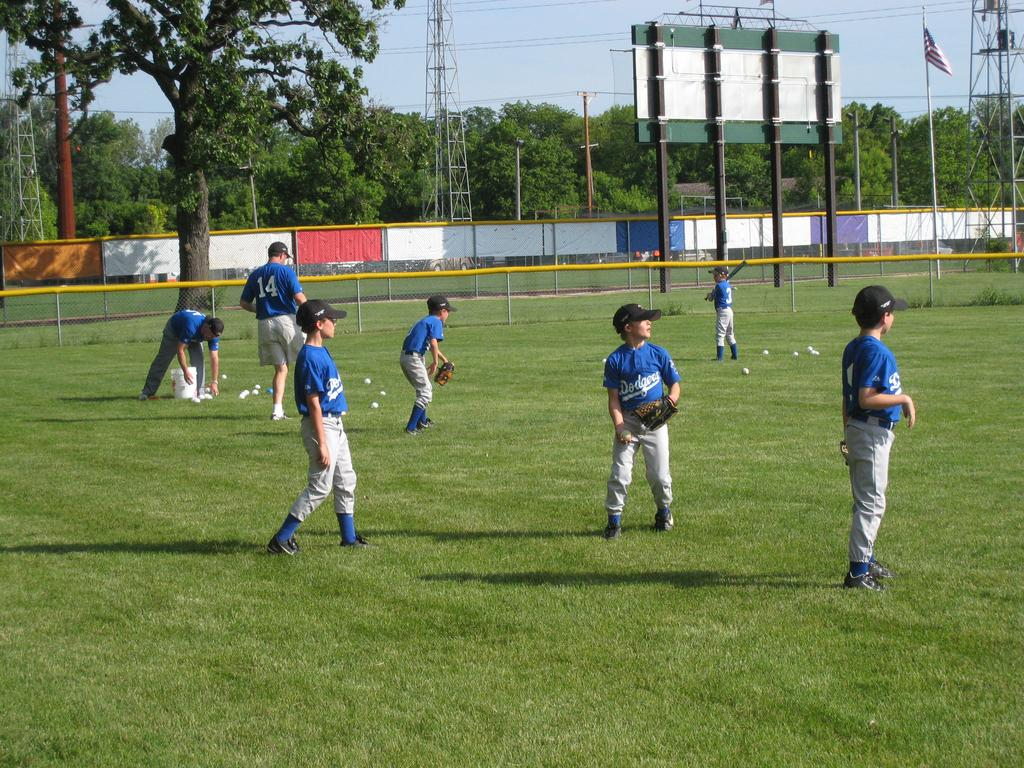What are the children in the image doing? The children are playing a game in the image. How many people are involved in the game? There are two persons in the ground. What can be seen in the background of the image? There are trees in the background of the image. What is surrounding the ground? There is fencing around the ground. What type of plants are growing on the children's thumbs in the image? There are no plants growing on the children's thumbs in the image. How many feet are visible in the image? The number of feet visible in the image cannot be determined from the provided facts. 